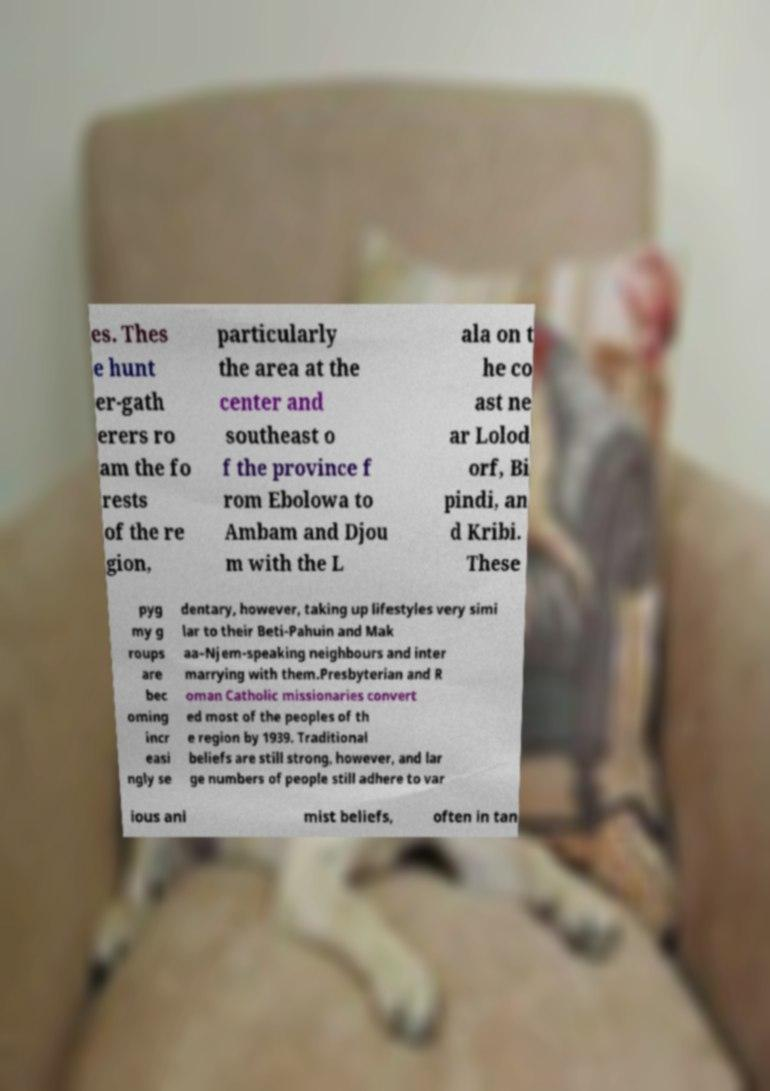What messages or text are displayed in this image? I need them in a readable, typed format. es. Thes e hunt er-gath erers ro am the fo rests of the re gion, particularly the area at the center and southeast o f the province f rom Ebolowa to Ambam and Djou m with the L ala on t he co ast ne ar Lolod orf, Bi pindi, an d Kribi. These pyg my g roups are bec oming incr easi ngly se dentary, however, taking up lifestyles very simi lar to their Beti-Pahuin and Mak aa–Njem-speaking neighbours and inter marrying with them.Presbyterian and R oman Catholic missionaries convert ed most of the peoples of th e region by 1939. Traditional beliefs are still strong, however, and lar ge numbers of people still adhere to var ious ani mist beliefs, often in tan 